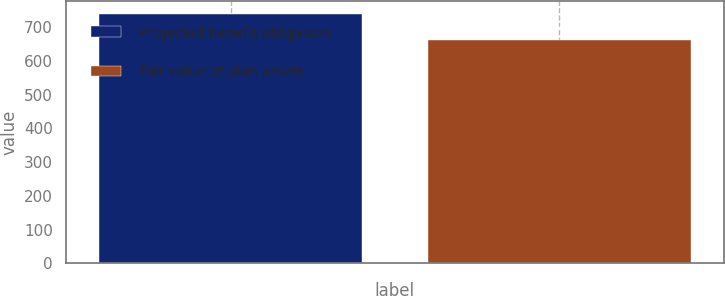Convert chart to OTSL. <chart><loc_0><loc_0><loc_500><loc_500><bar_chart><fcel>Projected benefit obligation<fcel>Fair value of plan assets<nl><fcel>739<fcel>663<nl></chart> 